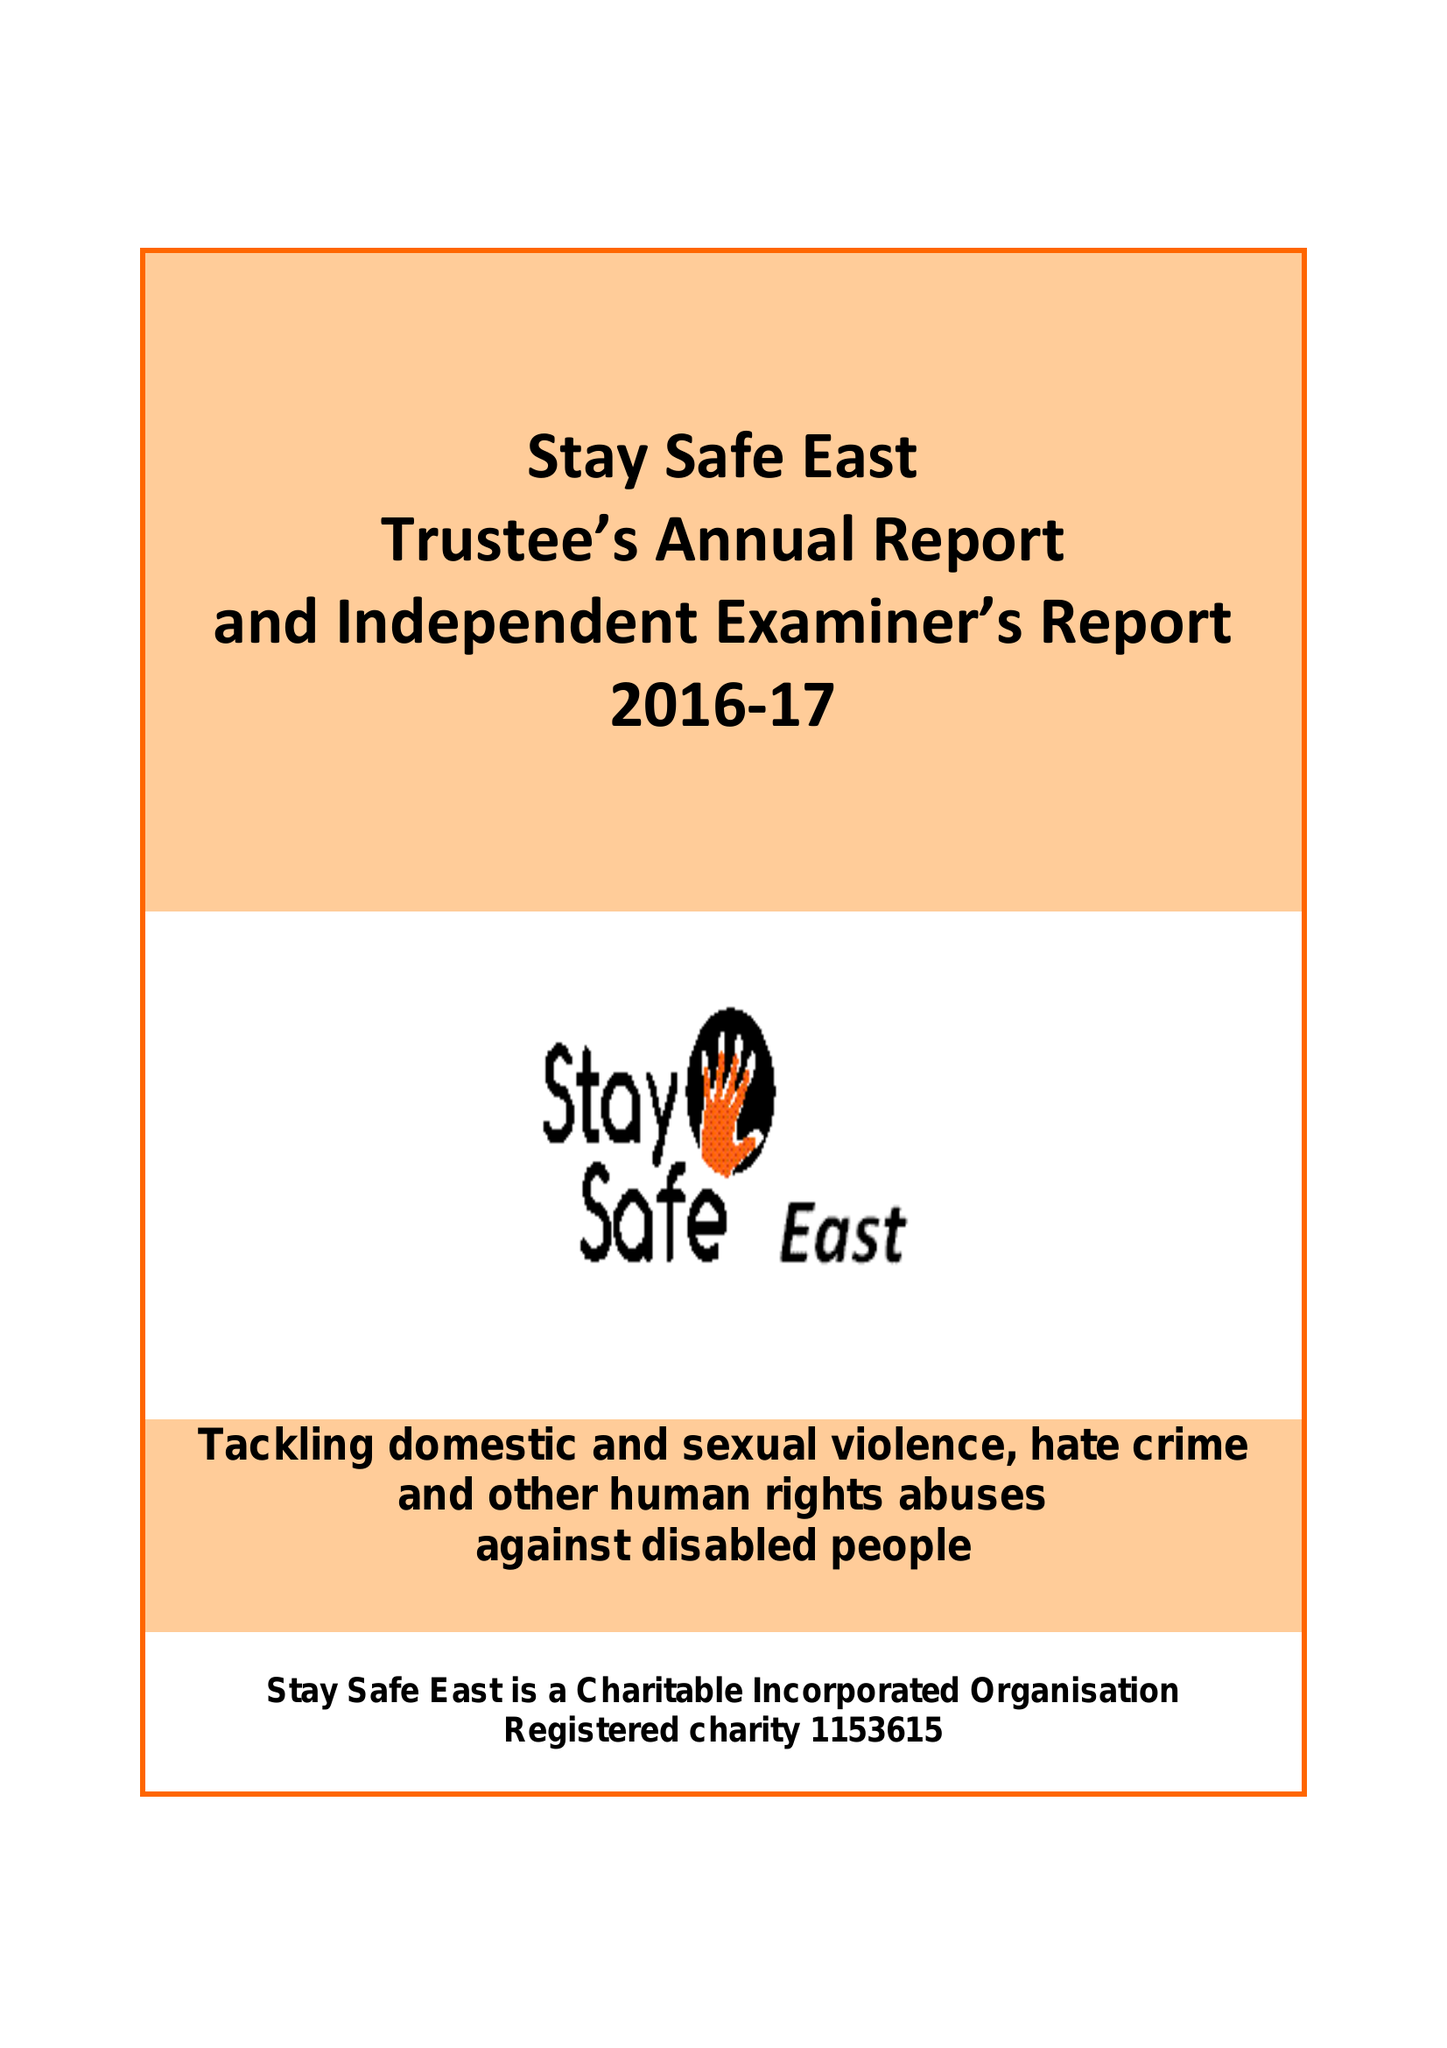What is the value for the address__postcode?
Answer the question using a single word or phrase. E15 2BG 